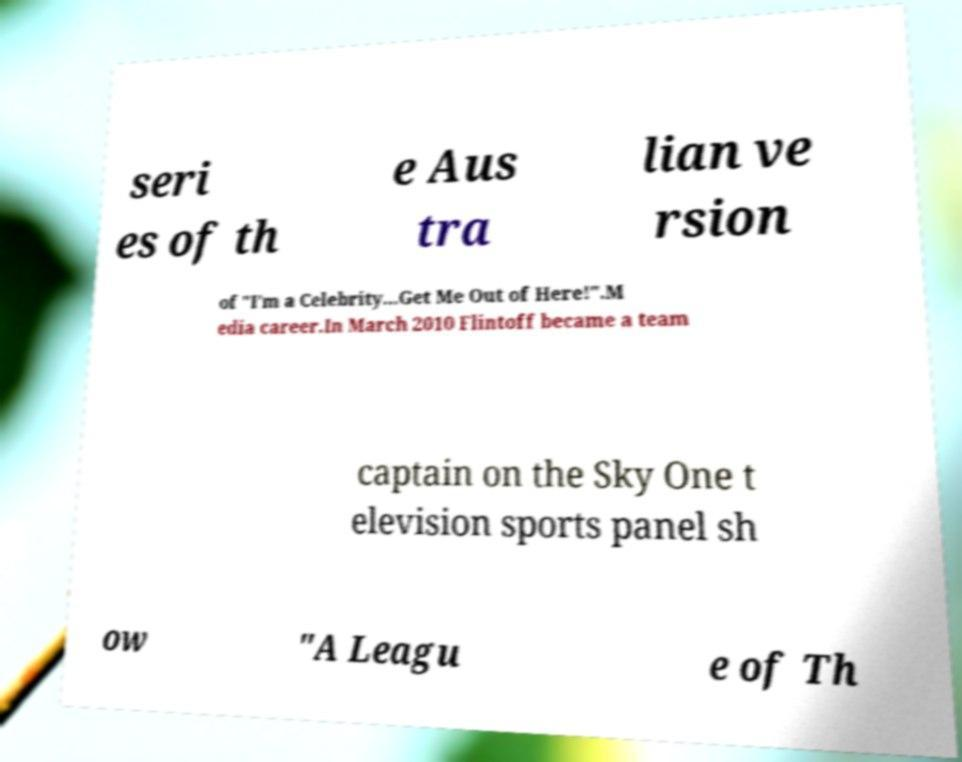Could you extract and type out the text from this image? seri es of th e Aus tra lian ve rsion of "I'm a Celebrity...Get Me Out of Here!".M edia career.In March 2010 Flintoff became a team captain on the Sky One t elevision sports panel sh ow "A Leagu e of Th 